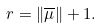<formula> <loc_0><loc_0><loc_500><loc_500>r = \| \overline { \mu } \| + 1 .</formula> 